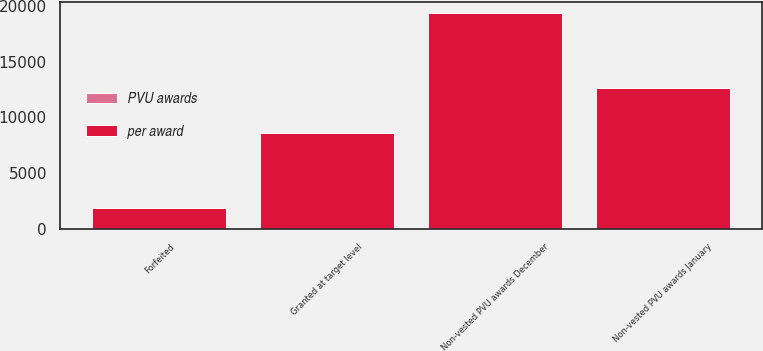<chart> <loc_0><loc_0><loc_500><loc_500><stacked_bar_chart><ecel><fcel>Non-vested PVU awards January<fcel>Granted at target level<fcel>Forfeited<fcel>Non-vested PVU awards December<nl><fcel>per award<fcel>12632<fcel>8523<fcel>1809<fcel>19346<nl><fcel>PVU awards<fcel>38.29<fcel>41.7<fcel>37.73<fcel>39.85<nl></chart> 